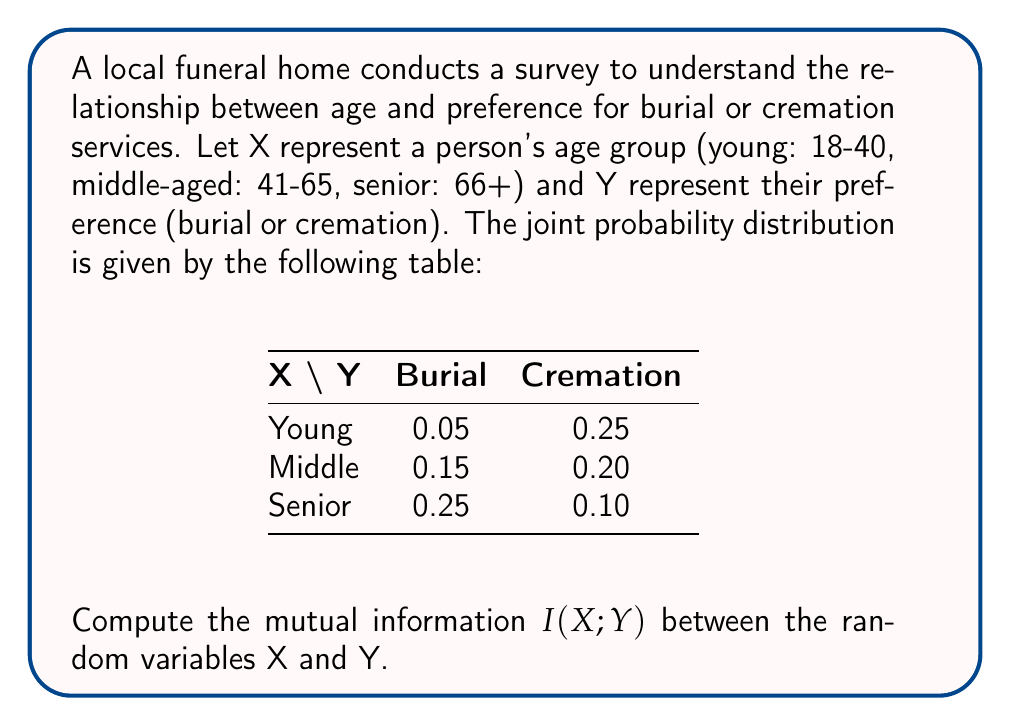What is the answer to this math problem? To compute the mutual information $I(X;Y)$, we'll follow these steps:

1. Calculate the marginal probabilities $P(X)$ and $P(Y)$.
2. Calculate the joint probabilities $P(X,Y)$.
3. Apply the formula for mutual information.

Step 1: Marginal probabilities

$P(X = \text{Young}) = 0.05 + 0.25 = 0.30$
$P(X = \text{Middle}) = 0.15 + 0.20 = 0.35$
$P(X = \text{Senior}) = 0.25 + 0.10 = 0.35$

$P(Y = \text{Burial}) = 0.05 + 0.15 + 0.25 = 0.45$
$P(Y = \text{Cremation}) = 0.25 + 0.20 + 0.10 = 0.55$

Step 2: Joint probabilities are given in the table.

Step 3: Apply the formula for mutual information

$$I(X;Y) = \sum_{x \in X} \sum_{y \in Y} P(x,y) \log_2 \frac{P(x,y)}{P(x)P(y)}$$

Calculate each term:

$0.05 \log_2 \frac{0.05}{0.30 \times 0.45} = 0.05 \log_2 0.3704 = -0.0702$
$0.25 \log_2 \frac{0.25}{0.30 \times 0.55} = 0.25 \log_2 1.5152 = 0.0932$
$0.15 \log_2 \frac{0.15}{0.35 \times 0.45} = 0.15 \log_2 0.9524 = -0.0011$
$0.20 \log_2 \frac{0.20}{0.35 \times 0.55} = 0.20 \log_2 1.0390 = 0.0022$
$0.25 \log_2 \frac{0.25}{0.35 \times 0.45} = 0.25 \log_2 1.5873 = 0.1133$
$0.10 \log_2 \frac{0.10}{0.35 \times 0.55} = 0.10 \log_2 0.5195 = -0.0610$

Sum all terms:

$I(X;Y) = -0.0702 + 0.0932 - 0.0011 + 0.0022 + 0.1133 - 0.0610 = 0.0764$ bits
Answer: The mutual information $I(X;Y)$ between age group and service preference is approximately 0.0764 bits. 